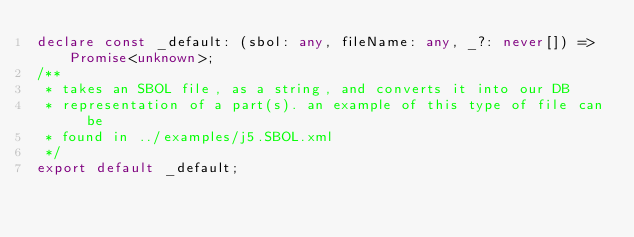Convert code to text. <code><loc_0><loc_0><loc_500><loc_500><_TypeScript_>declare const _default: (sbol: any, fileName: any, _?: never[]) => Promise<unknown>;
/**
 * takes an SBOL file, as a string, and converts it into our DB
 * representation of a part(s). an example of this type of file can be
 * found in ../examples/j5.SBOL.xml
 */
export default _default;
</code> 